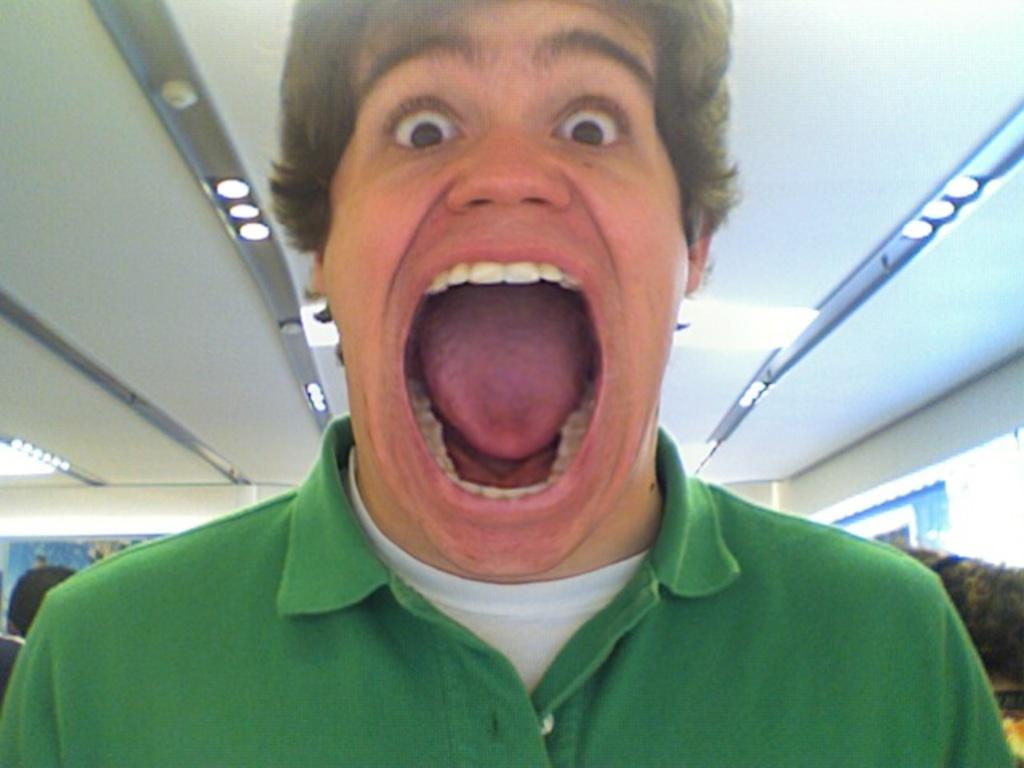Who or what is present in the image? There is a person in the image. What is the person wearing? The person is wearing a green t-shirt. What can be seen in the background of the image? There is a roof and ceiling lights in the background of the image. Are there any other objects visible in the background? Yes, there are other objects visible in the background of the image. What type of straw is the person holding in the image? There is no straw present in the image. How much salt is visible on the person's clothing in the image? There is no salt visible on the person's clothing in the image. 